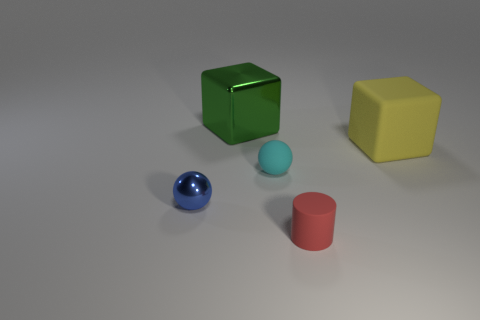The cube that is the same size as the yellow matte object is what color?
Give a very brief answer. Green. Is there another tiny thing of the same shape as the tiny cyan thing?
Keep it short and to the point. Yes. What color is the block that is in front of the metal thing that is behind the tiny ball that is behind the metallic sphere?
Your answer should be compact. Yellow. What number of metallic objects are small green objects or red cylinders?
Offer a terse response. 0. Is the number of big objects to the right of the small red matte object greater than the number of cylinders behind the shiny sphere?
Provide a short and direct response. Yes. How many other objects are the same size as the yellow block?
Give a very brief answer. 1. There is a shiny object in front of the rubber thing that is behind the cyan thing; what size is it?
Your response must be concise. Small. How many tiny things are red things or gray metal things?
Make the answer very short. 1. What size is the ball on the right side of the big thing that is to the left of the thing that is right of the rubber cylinder?
Make the answer very short. Small. Are there any other things that have the same color as the tiny matte cylinder?
Keep it short and to the point. No. 